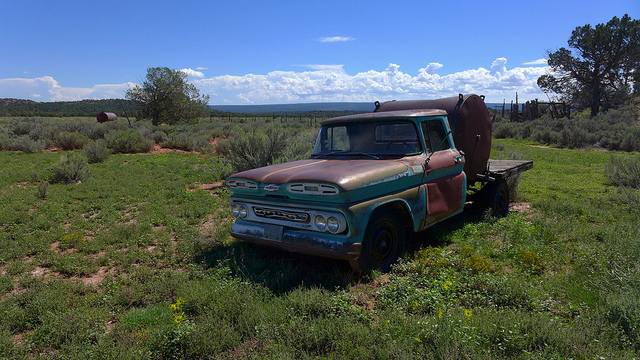What impact does this truck have on the landscape? This truck adds a historical and aesthetic layer to the landscape, contributing to a rustic and abandoned atmosphere. It serves as a reminder of past activities in the area, perhaps related to farming or transportation. Environmentally, if not carefully managed, it could pose risks such as leakage of old fluids into the ground. Could this truck still be operable with repairs? Potentially, yes. Many vintage trucks are restored to working condition with enough investment and effort. The key factors would include the state of its engine, transmission, and other critical mechanical systems, which would need a thorough evaluation by a mechanic experienced with vintage models. 